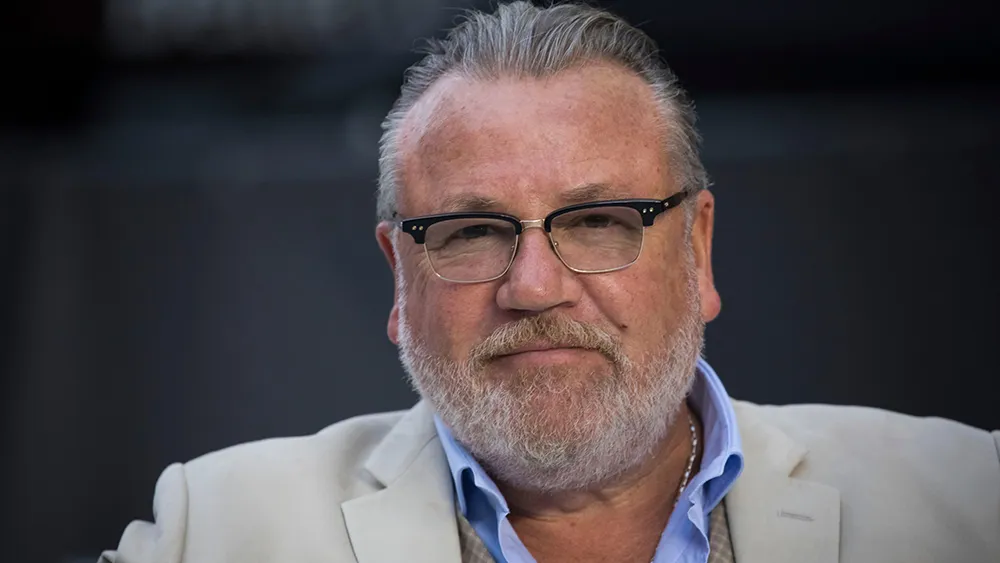Can you elaborate on the elements of the picture provided?
 In this image, the renowned actor Ray Winstone is captured in a moment of deep thought. He's donned in a crisp white blazer and a contrasting blue shirt, adding a touch of sophistication to his appearance. His gray beard and black glasses lend him an air of wisdom and experience. His gaze is directed off to the side, suggesting he's engrossed in contemplation. The serious expression on his face hints at the intensity of his thoughts. The blurred background, possibly a stage or a press conference, puts the focus squarely on him, underscoring his prominence in the scene. 